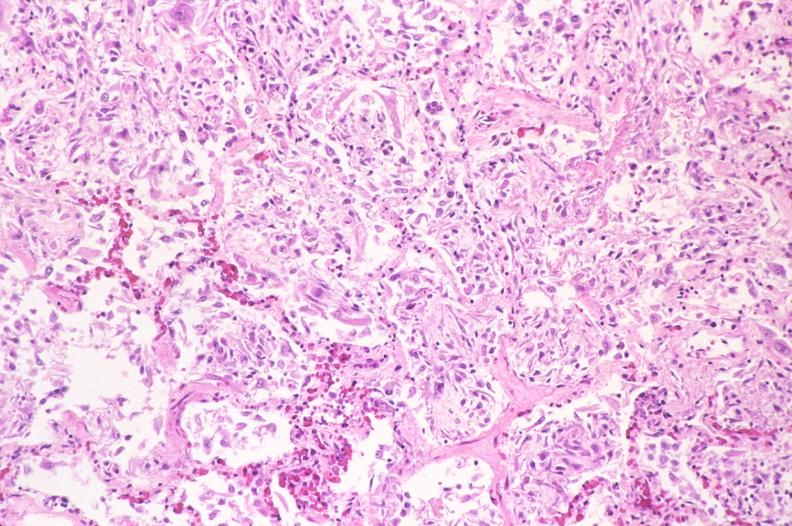where is this?
Answer the question using a single word or phrase. Lung 